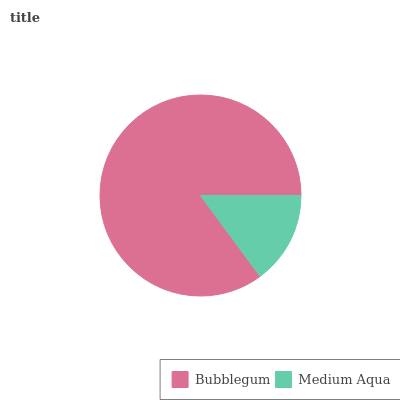Is Medium Aqua the minimum?
Answer yes or no. Yes. Is Bubblegum the maximum?
Answer yes or no. Yes. Is Medium Aqua the maximum?
Answer yes or no. No. Is Bubblegum greater than Medium Aqua?
Answer yes or no. Yes. Is Medium Aqua less than Bubblegum?
Answer yes or no. Yes. Is Medium Aqua greater than Bubblegum?
Answer yes or no. No. Is Bubblegum less than Medium Aqua?
Answer yes or no. No. Is Bubblegum the high median?
Answer yes or no. Yes. Is Medium Aqua the low median?
Answer yes or no. Yes. Is Medium Aqua the high median?
Answer yes or no. No. Is Bubblegum the low median?
Answer yes or no. No. 